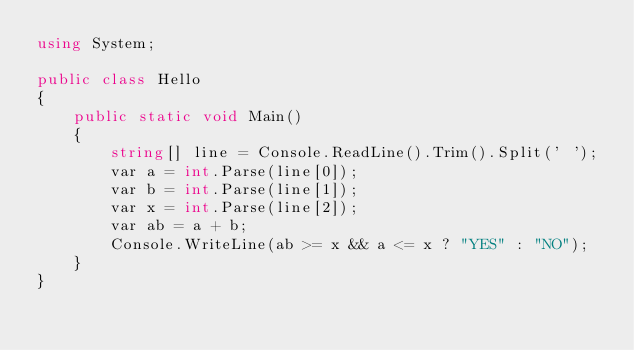<code> <loc_0><loc_0><loc_500><loc_500><_C#_>using System;

public class Hello
{
    public static void Main()
    {
        string[] line = Console.ReadLine().Trim().Split(' ');
        var a = int.Parse(line[0]);
        var b = int.Parse(line[1]);
        var x = int.Parse(line[2]);
        var ab = a + b;
        Console.WriteLine(ab >= x && a <= x ? "YES" : "NO");
    }
}
</code> 